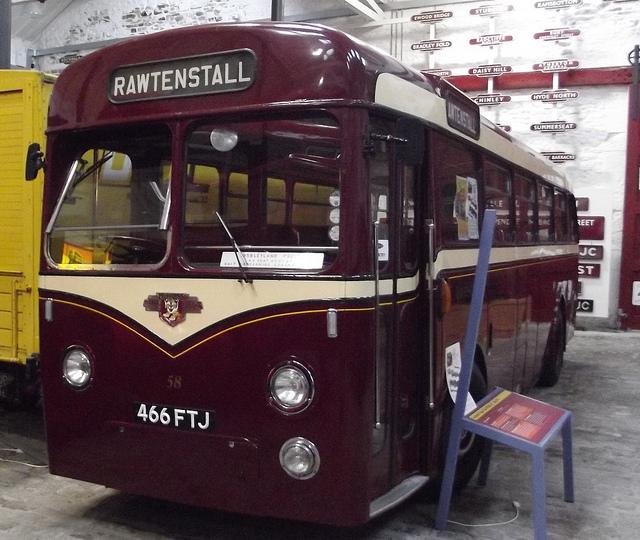What does the information on the blue legged placard describe? bus 